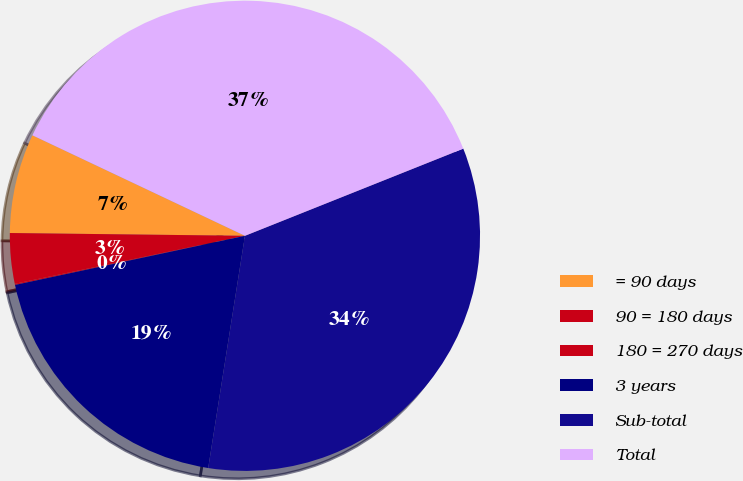Convert chart. <chart><loc_0><loc_0><loc_500><loc_500><pie_chart><fcel>= 90 days<fcel>90 = 180 days<fcel>180 = 270 days<fcel>3 years<fcel>Sub-total<fcel>Total<nl><fcel>6.84%<fcel>3.46%<fcel>0.08%<fcel>19.15%<fcel>33.54%<fcel>36.92%<nl></chart> 